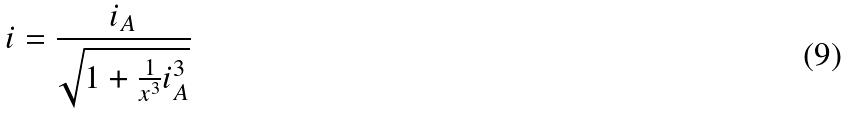Convert formula to latex. <formula><loc_0><loc_0><loc_500><loc_500>i = \frac { i _ { A } } { \sqrt { 1 + \frac { 1 } { x ^ { 3 } } i _ { A } ^ { 3 } } }</formula> 